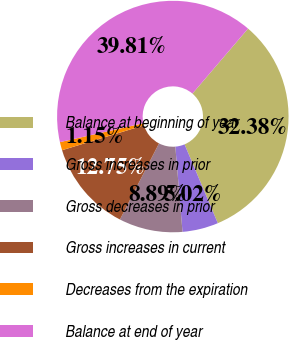Convert chart. <chart><loc_0><loc_0><loc_500><loc_500><pie_chart><fcel>Balance at beginning of year<fcel>Gross increases in prior<fcel>Gross decreases in prior<fcel>Gross increases in current<fcel>Decreases from the expiration<fcel>Balance at end of year<nl><fcel>32.38%<fcel>5.02%<fcel>8.89%<fcel>12.75%<fcel>1.15%<fcel>39.81%<nl></chart> 